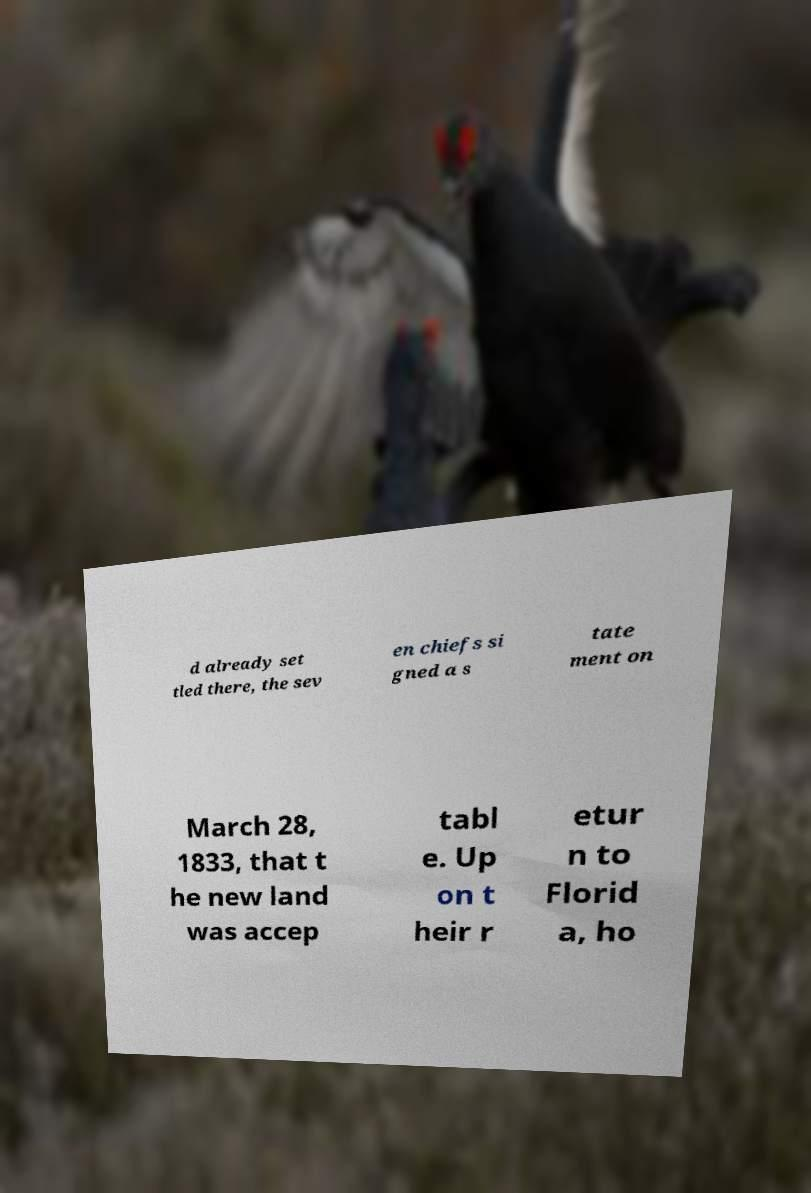Can you accurately transcribe the text from the provided image for me? d already set tled there, the sev en chiefs si gned a s tate ment on March 28, 1833, that t he new land was accep tabl e. Up on t heir r etur n to Florid a, ho 